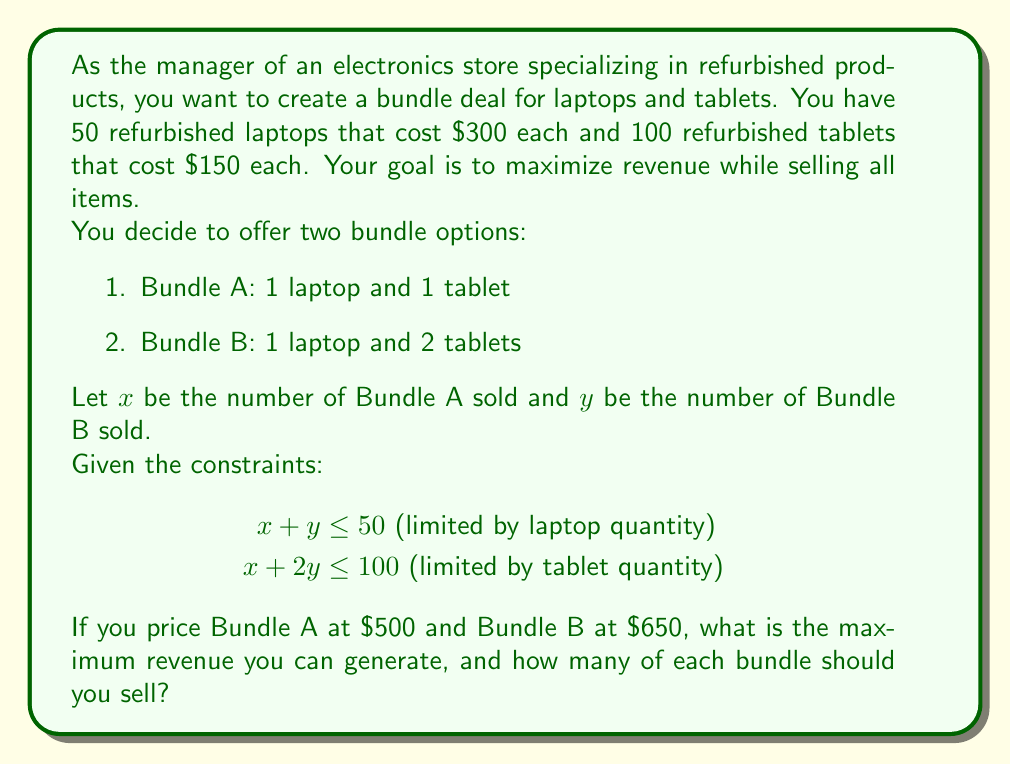What is the answer to this math problem? To solve this problem, we'll use linear programming techniques:

1. Define the objective function:
   Revenue = $500x + 650y$

2. List the constraints:
   $x + y \leq 50$
   $x + 2y \leq 100$
   $x \geq 0, y \geq 0$

3. Graph the constraints:
   [asy]
   import graph;
   size(200);
   xaxis("x", 0, 60);
   yaxis("y", 0, 60);
   draw((0,50)--(50,0), blue);
   draw((0,50)--(100,0), red);
   label("x + y = 50", (25,25), N, blue);
   label("x + 2y = 100", (50,25), N, red);
   fill((0,0)--(50,0)--(50,25)--(0,50)--cycle, palegreen+opacity(0.2));
   [/asy]

4. Identify the corner points of the feasible region:
   (0,0), (50,0), (0,50), and the intersection of the two constraint lines.

5. Find the intersection point:
   $x + y = 50$
   $x + 2y = 100$
   Subtracting the first equation from the second:
   $y = 50$
   Substituting back into $x + y = 50$:
   $x + 50 = 50$
   $x = 0$
   So, the intersection point is (0,50).

6. Evaluate the objective function at each corner point:
   (0,0): Revenue = $0
   (50,0): Revenue = $500(50) + 650(0) = $25,000
   (0,50): Revenue = $500(0) + 650(50) = $32,500
   (0,50): Revenue = $500(0) + 650(50) = $32,500

7. The maximum revenue occurs at (0,50), which means selling 50 of Bundle B.
Answer: The maximum revenue is $32,500, achieved by selling 0 of Bundle A and 50 of Bundle B. 